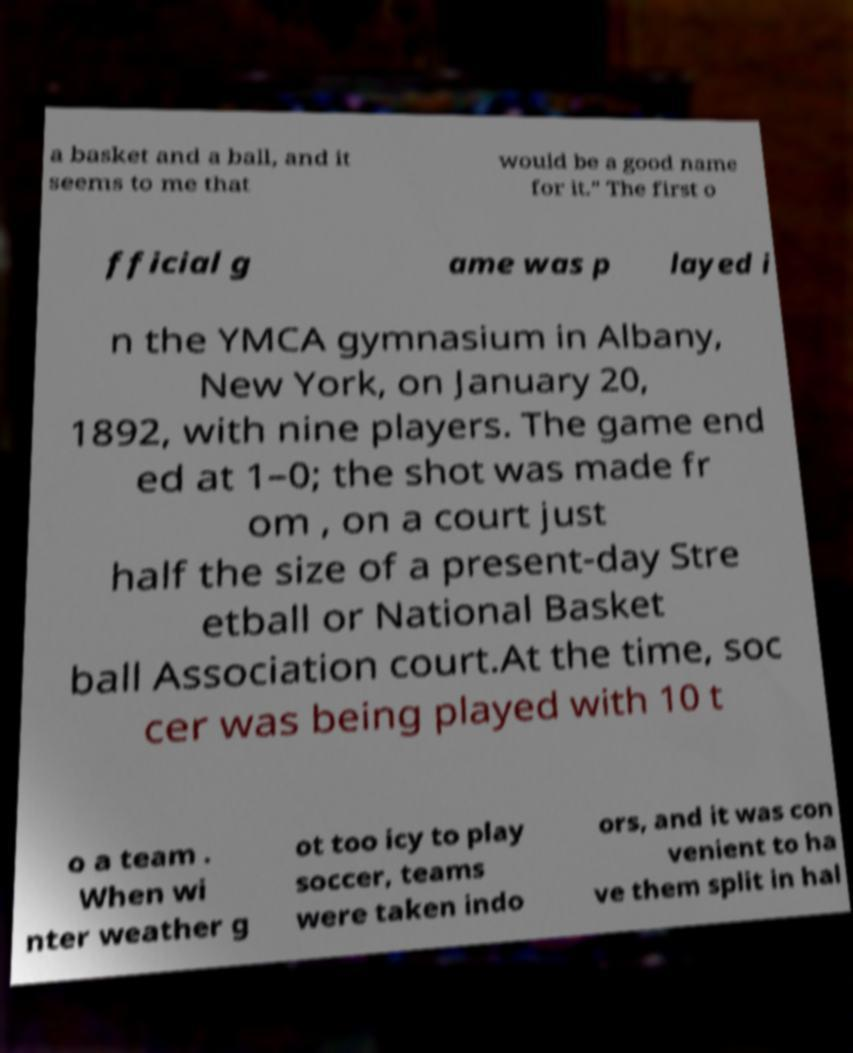I need the written content from this picture converted into text. Can you do that? a basket and a ball, and it seems to me that would be a good name for it." The first o fficial g ame was p layed i n the YMCA gymnasium in Albany, New York, on January 20, 1892, with nine players. The game end ed at 1–0; the shot was made fr om , on a court just half the size of a present-day Stre etball or National Basket ball Association court.At the time, soc cer was being played with 10 t o a team . When wi nter weather g ot too icy to play soccer, teams were taken indo ors, and it was con venient to ha ve them split in hal 